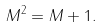<formula> <loc_0><loc_0><loc_500><loc_500>M ^ { 2 } = M + 1 .</formula> 